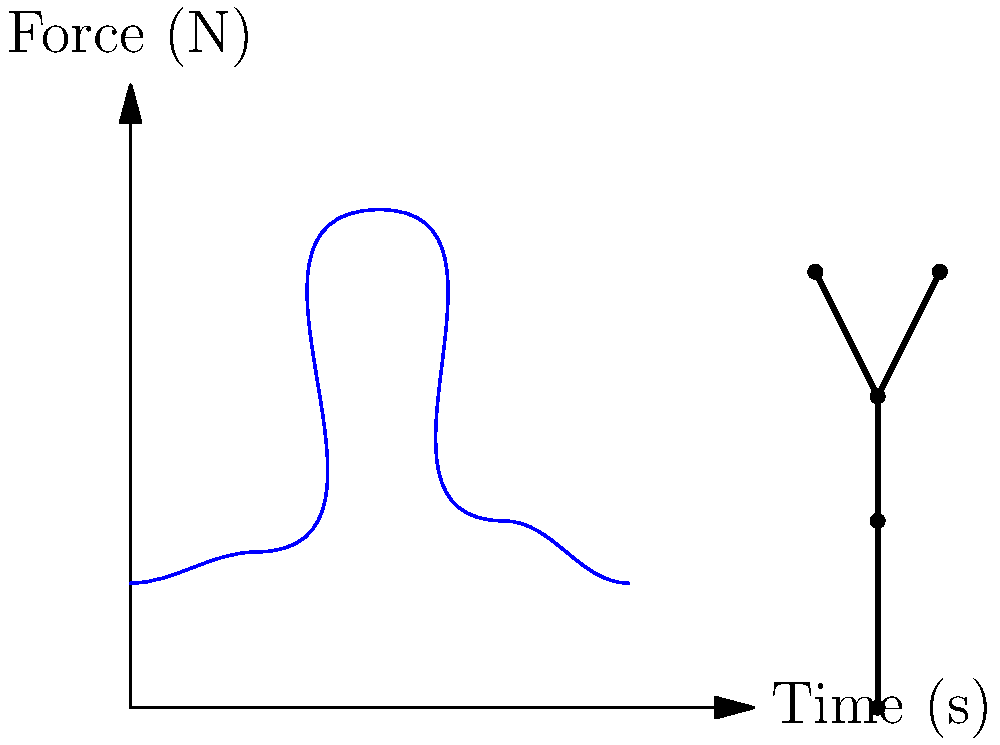A student athlete performs a vertical jump on a force plate. The graph shows the vertical ground reaction force over time during the jump. If the athlete's mass is 70 kg, calculate the maximum vertical acceleration of their center of mass during the jump. Express your answer in terms of g (acceleration due to gravity, 9.8 m/s²). To solve this problem, we'll follow these steps:

1) Identify the peak force from the graph:
   The maximum force appears to be about 8 times the initial force.

2) Calculate the initial force (athlete's weight):
   $F_initial = mg = 70 \text{ kg} \times 9.8 \text{ m/s}^2 = 686 \text{ N}$

3) Calculate the peak force:
   $F_peak \approx 8 \times 686 \text{ N} = 5488 \text{ N}$

4) Calculate the net force at peak:
   $F_net = F_peak - F_initial = 5488 \text{ N} - 686 \text{ N} = 4802 \text{ N}$

5) Use Newton's Second Law to find acceleration:
   $F = ma$
   $a = \frac{F}{m} = \frac{4802 \text{ N}}{70 \text{ kg}} = 68.6 \text{ m/s}^2$

6) Express acceleration in terms of g:
   $\frac{68.6 \text{ m/s}^2}{9.8 \text{ m/s}^2} \approx 7g$

Therefore, the maximum vertical acceleration of the athlete's center of mass during the jump is approximately 7g.
Answer: 7g 